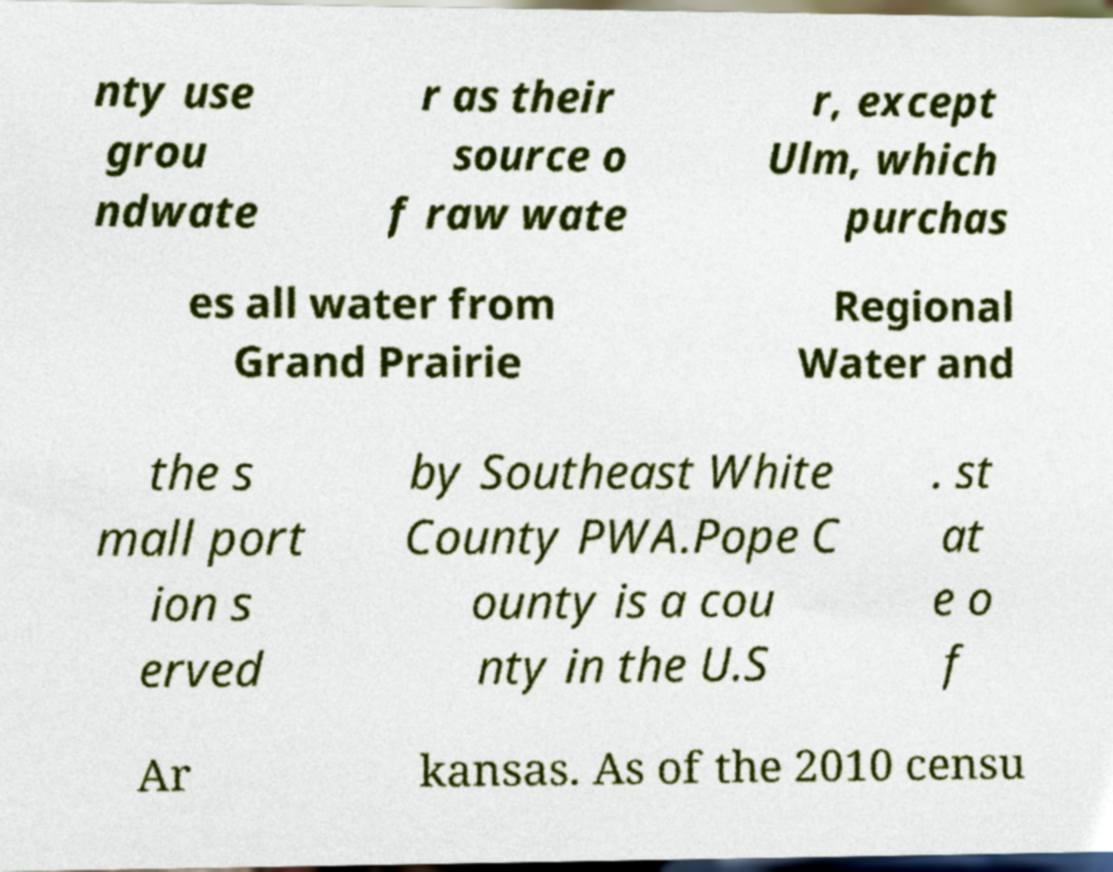There's text embedded in this image that I need extracted. Can you transcribe it verbatim? nty use grou ndwate r as their source o f raw wate r, except Ulm, which purchas es all water from Grand Prairie Regional Water and the s mall port ion s erved by Southeast White County PWA.Pope C ounty is a cou nty in the U.S . st at e o f Ar kansas. As of the 2010 censu 